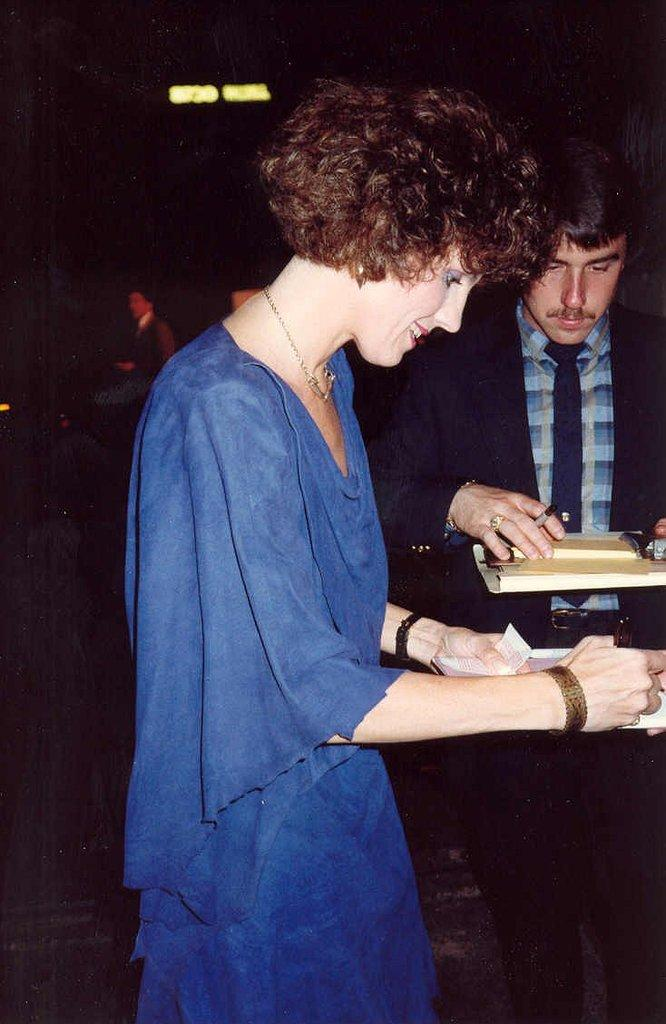What are the two people in the image doing? The two people in the image are standing and holding objects. Can you describe the third person in the image? There is another person standing behind them. What can be observed about the lighting in the image? The background is dark, but there are lights visible in the background. What type of roof can be seen on the box in the image? There is no box or roof present in the image. 